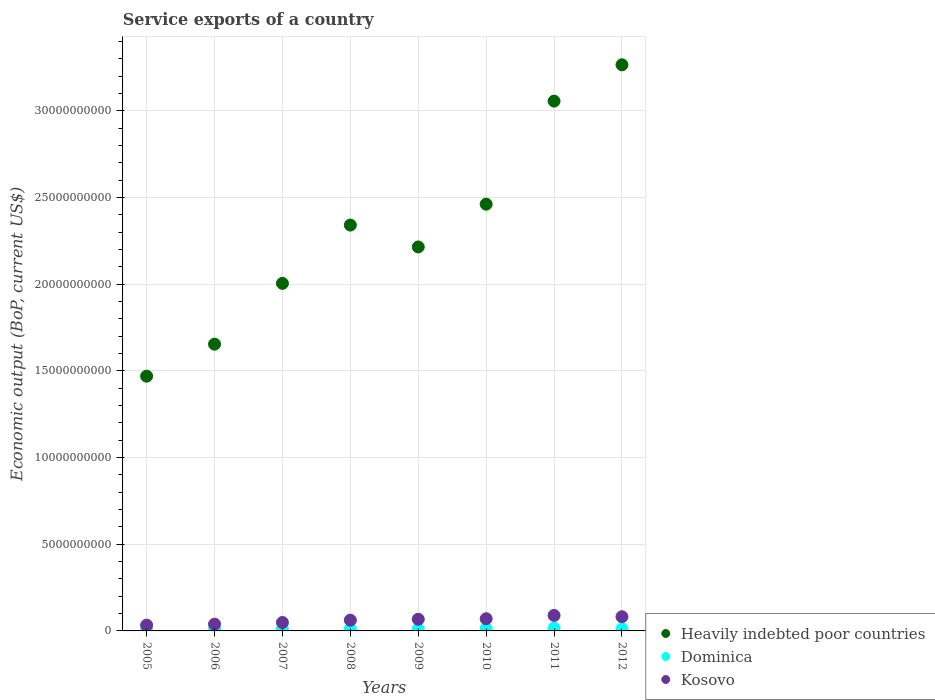What is the service exports in Kosovo in 2010?
Offer a terse response. 7.04e+08. Across all years, what is the maximum service exports in Dominica?
Provide a short and direct response. 1.55e+08. Across all years, what is the minimum service exports in Kosovo?
Your response must be concise. 3.33e+08. In which year was the service exports in Kosovo maximum?
Make the answer very short. 2011. What is the total service exports in Dominica in the graph?
Make the answer very short. 9.33e+08. What is the difference between the service exports in Dominica in 2009 and that in 2010?
Provide a short and direct response. -2.57e+07. What is the difference between the service exports in Kosovo in 2007 and the service exports in Heavily indebted poor countries in 2012?
Provide a short and direct response. -3.22e+1. What is the average service exports in Heavily indebted poor countries per year?
Your answer should be compact. 2.31e+1. In the year 2012, what is the difference between the service exports in Dominica and service exports in Heavily indebted poor countries?
Ensure brevity in your answer.  -3.25e+1. What is the ratio of the service exports in Kosovo in 2007 to that in 2009?
Make the answer very short. 0.72. Is the difference between the service exports in Dominica in 2007 and 2011 greater than the difference between the service exports in Heavily indebted poor countries in 2007 and 2011?
Provide a succinct answer. Yes. What is the difference between the highest and the second highest service exports in Dominica?
Your response must be concise. 1.80e+07. What is the difference between the highest and the lowest service exports in Kosovo?
Make the answer very short. 5.60e+08. In how many years, is the service exports in Dominica greater than the average service exports in Dominica taken over all years?
Offer a very short reply. 3. Is the sum of the service exports in Kosovo in 2005 and 2010 greater than the maximum service exports in Dominica across all years?
Your answer should be very brief. Yes. Is it the case that in every year, the sum of the service exports in Dominica and service exports in Kosovo  is greater than the service exports in Heavily indebted poor countries?
Keep it short and to the point. No. Is the service exports in Kosovo strictly less than the service exports in Heavily indebted poor countries over the years?
Give a very brief answer. Yes. How many dotlines are there?
Provide a succinct answer. 3. How many years are there in the graph?
Provide a short and direct response. 8. What is the difference between two consecutive major ticks on the Y-axis?
Your answer should be compact. 5.00e+09. Are the values on the major ticks of Y-axis written in scientific E-notation?
Ensure brevity in your answer.  No. Does the graph contain any zero values?
Your answer should be compact. No. Does the graph contain grids?
Keep it short and to the point. Yes. Where does the legend appear in the graph?
Offer a terse response. Bottom right. How are the legend labels stacked?
Your answer should be compact. Vertical. What is the title of the graph?
Your response must be concise. Service exports of a country. Does "Chad" appear as one of the legend labels in the graph?
Provide a succinct answer. No. What is the label or title of the X-axis?
Keep it short and to the point. Years. What is the label or title of the Y-axis?
Keep it short and to the point. Economic output (BoP, current US$). What is the Economic output (BoP, current US$) of Heavily indebted poor countries in 2005?
Your answer should be compact. 1.47e+1. What is the Economic output (BoP, current US$) in Dominica in 2005?
Provide a short and direct response. 8.64e+07. What is the Economic output (BoP, current US$) of Kosovo in 2005?
Your response must be concise. 3.33e+08. What is the Economic output (BoP, current US$) in Heavily indebted poor countries in 2006?
Your response must be concise. 1.65e+1. What is the Economic output (BoP, current US$) of Dominica in 2006?
Your answer should be very brief. 1.00e+08. What is the Economic output (BoP, current US$) of Kosovo in 2006?
Provide a succinct answer. 3.91e+08. What is the Economic output (BoP, current US$) in Heavily indebted poor countries in 2007?
Keep it short and to the point. 2.00e+1. What is the Economic output (BoP, current US$) of Dominica in 2007?
Keep it short and to the point. 1.09e+08. What is the Economic output (BoP, current US$) of Kosovo in 2007?
Provide a succinct answer. 4.86e+08. What is the Economic output (BoP, current US$) of Heavily indebted poor countries in 2008?
Provide a short and direct response. 2.34e+1. What is the Economic output (BoP, current US$) of Dominica in 2008?
Offer a very short reply. 1.13e+08. What is the Economic output (BoP, current US$) in Kosovo in 2008?
Ensure brevity in your answer.  6.20e+08. What is the Economic output (BoP, current US$) of Heavily indebted poor countries in 2009?
Provide a succinct answer. 2.21e+1. What is the Economic output (BoP, current US$) of Dominica in 2009?
Offer a very short reply. 1.11e+08. What is the Economic output (BoP, current US$) in Kosovo in 2009?
Your response must be concise. 6.73e+08. What is the Economic output (BoP, current US$) of Heavily indebted poor countries in 2010?
Ensure brevity in your answer.  2.46e+1. What is the Economic output (BoP, current US$) in Dominica in 2010?
Provide a short and direct response. 1.37e+08. What is the Economic output (BoP, current US$) of Kosovo in 2010?
Provide a short and direct response. 7.04e+08. What is the Economic output (BoP, current US$) of Heavily indebted poor countries in 2011?
Give a very brief answer. 3.06e+1. What is the Economic output (BoP, current US$) in Dominica in 2011?
Offer a very short reply. 1.55e+08. What is the Economic output (BoP, current US$) in Kosovo in 2011?
Make the answer very short. 8.93e+08. What is the Economic output (BoP, current US$) in Heavily indebted poor countries in 2012?
Provide a succinct answer. 3.27e+1. What is the Economic output (BoP, current US$) in Dominica in 2012?
Your response must be concise. 1.22e+08. What is the Economic output (BoP, current US$) of Kosovo in 2012?
Make the answer very short. 8.19e+08. Across all years, what is the maximum Economic output (BoP, current US$) in Heavily indebted poor countries?
Offer a very short reply. 3.27e+1. Across all years, what is the maximum Economic output (BoP, current US$) of Dominica?
Your answer should be compact. 1.55e+08. Across all years, what is the maximum Economic output (BoP, current US$) in Kosovo?
Offer a terse response. 8.93e+08. Across all years, what is the minimum Economic output (BoP, current US$) in Heavily indebted poor countries?
Keep it short and to the point. 1.47e+1. Across all years, what is the minimum Economic output (BoP, current US$) of Dominica?
Make the answer very short. 8.64e+07. Across all years, what is the minimum Economic output (BoP, current US$) of Kosovo?
Provide a succinct answer. 3.33e+08. What is the total Economic output (BoP, current US$) of Heavily indebted poor countries in the graph?
Offer a very short reply. 1.85e+11. What is the total Economic output (BoP, current US$) in Dominica in the graph?
Your answer should be very brief. 9.33e+08. What is the total Economic output (BoP, current US$) of Kosovo in the graph?
Provide a short and direct response. 4.92e+09. What is the difference between the Economic output (BoP, current US$) in Heavily indebted poor countries in 2005 and that in 2006?
Provide a succinct answer. -1.85e+09. What is the difference between the Economic output (BoP, current US$) in Dominica in 2005 and that in 2006?
Ensure brevity in your answer.  -1.37e+07. What is the difference between the Economic output (BoP, current US$) of Kosovo in 2005 and that in 2006?
Offer a terse response. -5.80e+07. What is the difference between the Economic output (BoP, current US$) in Heavily indebted poor countries in 2005 and that in 2007?
Your response must be concise. -5.35e+09. What is the difference between the Economic output (BoP, current US$) of Dominica in 2005 and that in 2007?
Keep it short and to the point. -2.24e+07. What is the difference between the Economic output (BoP, current US$) of Kosovo in 2005 and that in 2007?
Your answer should be very brief. -1.53e+08. What is the difference between the Economic output (BoP, current US$) of Heavily indebted poor countries in 2005 and that in 2008?
Provide a short and direct response. -8.71e+09. What is the difference between the Economic output (BoP, current US$) of Dominica in 2005 and that in 2008?
Provide a short and direct response. -2.64e+07. What is the difference between the Economic output (BoP, current US$) of Kosovo in 2005 and that in 2008?
Give a very brief answer. -2.87e+08. What is the difference between the Economic output (BoP, current US$) of Heavily indebted poor countries in 2005 and that in 2009?
Your answer should be compact. -7.45e+09. What is the difference between the Economic output (BoP, current US$) in Dominica in 2005 and that in 2009?
Provide a succinct answer. -2.47e+07. What is the difference between the Economic output (BoP, current US$) in Kosovo in 2005 and that in 2009?
Your answer should be compact. -3.40e+08. What is the difference between the Economic output (BoP, current US$) in Heavily indebted poor countries in 2005 and that in 2010?
Provide a short and direct response. -9.92e+09. What is the difference between the Economic output (BoP, current US$) in Dominica in 2005 and that in 2010?
Your answer should be very brief. -5.04e+07. What is the difference between the Economic output (BoP, current US$) in Kosovo in 2005 and that in 2010?
Offer a terse response. -3.71e+08. What is the difference between the Economic output (BoP, current US$) of Heavily indebted poor countries in 2005 and that in 2011?
Give a very brief answer. -1.59e+1. What is the difference between the Economic output (BoP, current US$) of Dominica in 2005 and that in 2011?
Offer a very short reply. -6.83e+07. What is the difference between the Economic output (BoP, current US$) in Kosovo in 2005 and that in 2011?
Offer a very short reply. -5.60e+08. What is the difference between the Economic output (BoP, current US$) of Heavily indebted poor countries in 2005 and that in 2012?
Ensure brevity in your answer.  -1.80e+1. What is the difference between the Economic output (BoP, current US$) of Dominica in 2005 and that in 2012?
Make the answer very short. -3.52e+07. What is the difference between the Economic output (BoP, current US$) in Kosovo in 2005 and that in 2012?
Offer a very short reply. -4.85e+08. What is the difference between the Economic output (BoP, current US$) of Heavily indebted poor countries in 2006 and that in 2007?
Offer a terse response. -3.51e+09. What is the difference between the Economic output (BoP, current US$) of Dominica in 2006 and that in 2007?
Your response must be concise. -8.65e+06. What is the difference between the Economic output (BoP, current US$) of Kosovo in 2006 and that in 2007?
Provide a short and direct response. -9.52e+07. What is the difference between the Economic output (BoP, current US$) in Heavily indebted poor countries in 2006 and that in 2008?
Make the answer very short. -6.87e+09. What is the difference between the Economic output (BoP, current US$) in Dominica in 2006 and that in 2008?
Give a very brief answer. -1.27e+07. What is the difference between the Economic output (BoP, current US$) in Kosovo in 2006 and that in 2008?
Your answer should be compact. -2.29e+08. What is the difference between the Economic output (BoP, current US$) of Heavily indebted poor countries in 2006 and that in 2009?
Your answer should be very brief. -5.61e+09. What is the difference between the Economic output (BoP, current US$) in Dominica in 2006 and that in 2009?
Keep it short and to the point. -1.10e+07. What is the difference between the Economic output (BoP, current US$) in Kosovo in 2006 and that in 2009?
Keep it short and to the point. -2.82e+08. What is the difference between the Economic output (BoP, current US$) of Heavily indebted poor countries in 2006 and that in 2010?
Provide a succinct answer. -8.07e+09. What is the difference between the Economic output (BoP, current US$) of Dominica in 2006 and that in 2010?
Ensure brevity in your answer.  -3.67e+07. What is the difference between the Economic output (BoP, current US$) of Kosovo in 2006 and that in 2010?
Keep it short and to the point. -3.13e+08. What is the difference between the Economic output (BoP, current US$) in Heavily indebted poor countries in 2006 and that in 2011?
Offer a terse response. -1.40e+1. What is the difference between the Economic output (BoP, current US$) of Dominica in 2006 and that in 2011?
Your answer should be very brief. -5.46e+07. What is the difference between the Economic output (BoP, current US$) of Kosovo in 2006 and that in 2011?
Provide a short and direct response. -5.02e+08. What is the difference between the Economic output (BoP, current US$) in Heavily indebted poor countries in 2006 and that in 2012?
Keep it short and to the point. -1.61e+1. What is the difference between the Economic output (BoP, current US$) in Dominica in 2006 and that in 2012?
Offer a terse response. -2.15e+07. What is the difference between the Economic output (BoP, current US$) of Kosovo in 2006 and that in 2012?
Offer a very short reply. -4.27e+08. What is the difference between the Economic output (BoP, current US$) in Heavily indebted poor countries in 2007 and that in 2008?
Offer a very short reply. -3.36e+09. What is the difference between the Economic output (BoP, current US$) in Dominica in 2007 and that in 2008?
Your answer should be compact. -4.02e+06. What is the difference between the Economic output (BoP, current US$) of Kosovo in 2007 and that in 2008?
Keep it short and to the point. -1.34e+08. What is the difference between the Economic output (BoP, current US$) of Heavily indebted poor countries in 2007 and that in 2009?
Offer a terse response. -2.10e+09. What is the difference between the Economic output (BoP, current US$) in Dominica in 2007 and that in 2009?
Provide a succinct answer. -2.31e+06. What is the difference between the Economic output (BoP, current US$) in Kosovo in 2007 and that in 2009?
Provide a succinct answer. -1.87e+08. What is the difference between the Economic output (BoP, current US$) of Heavily indebted poor countries in 2007 and that in 2010?
Provide a short and direct response. -4.57e+09. What is the difference between the Economic output (BoP, current US$) of Dominica in 2007 and that in 2010?
Give a very brief answer. -2.80e+07. What is the difference between the Economic output (BoP, current US$) of Kosovo in 2007 and that in 2010?
Provide a short and direct response. -2.17e+08. What is the difference between the Economic output (BoP, current US$) of Heavily indebted poor countries in 2007 and that in 2011?
Your answer should be very brief. -1.05e+1. What is the difference between the Economic output (BoP, current US$) of Dominica in 2007 and that in 2011?
Your response must be concise. -4.60e+07. What is the difference between the Economic output (BoP, current US$) in Kosovo in 2007 and that in 2011?
Keep it short and to the point. -4.07e+08. What is the difference between the Economic output (BoP, current US$) in Heavily indebted poor countries in 2007 and that in 2012?
Offer a terse response. -1.26e+1. What is the difference between the Economic output (BoP, current US$) in Dominica in 2007 and that in 2012?
Your answer should be very brief. -1.28e+07. What is the difference between the Economic output (BoP, current US$) in Kosovo in 2007 and that in 2012?
Offer a very short reply. -3.32e+08. What is the difference between the Economic output (BoP, current US$) of Heavily indebted poor countries in 2008 and that in 2009?
Provide a succinct answer. 1.26e+09. What is the difference between the Economic output (BoP, current US$) in Dominica in 2008 and that in 2009?
Provide a short and direct response. 1.71e+06. What is the difference between the Economic output (BoP, current US$) in Kosovo in 2008 and that in 2009?
Provide a succinct answer. -5.27e+07. What is the difference between the Economic output (BoP, current US$) in Heavily indebted poor countries in 2008 and that in 2010?
Offer a very short reply. -1.20e+09. What is the difference between the Economic output (BoP, current US$) of Dominica in 2008 and that in 2010?
Your answer should be very brief. -2.40e+07. What is the difference between the Economic output (BoP, current US$) of Kosovo in 2008 and that in 2010?
Provide a short and direct response. -8.37e+07. What is the difference between the Economic output (BoP, current US$) of Heavily indebted poor countries in 2008 and that in 2011?
Make the answer very short. -7.15e+09. What is the difference between the Economic output (BoP, current US$) of Dominica in 2008 and that in 2011?
Your answer should be very brief. -4.19e+07. What is the difference between the Economic output (BoP, current US$) in Kosovo in 2008 and that in 2011?
Ensure brevity in your answer.  -2.73e+08. What is the difference between the Economic output (BoP, current US$) in Heavily indebted poor countries in 2008 and that in 2012?
Make the answer very short. -9.24e+09. What is the difference between the Economic output (BoP, current US$) in Dominica in 2008 and that in 2012?
Keep it short and to the point. -8.82e+06. What is the difference between the Economic output (BoP, current US$) in Kosovo in 2008 and that in 2012?
Provide a short and direct response. -1.98e+08. What is the difference between the Economic output (BoP, current US$) of Heavily indebted poor countries in 2009 and that in 2010?
Your response must be concise. -2.47e+09. What is the difference between the Economic output (BoP, current US$) in Dominica in 2009 and that in 2010?
Provide a succinct answer. -2.57e+07. What is the difference between the Economic output (BoP, current US$) in Kosovo in 2009 and that in 2010?
Offer a terse response. -3.09e+07. What is the difference between the Economic output (BoP, current US$) in Heavily indebted poor countries in 2009 and that in 2011?
Your response must be concise. -8.41e+09. What is the difference between the Economic output (BoP, current US$) in Dominica in 2009 and that in 2011?
Offer a terse response. -4.37e+07. What is the difference between the Economic output (BoP, current US$) in Kosovo in 2009 and that in 2011?
Provide a succinct answer. -2.20e+08. What is the difference between the Economic output (BoP, current US$) of Heavily indebted poor countries in 2009 and that in 2012?
Keep it short and to the point. -1.05e+1. What is the difference between the Economic output (BoP, current US$) of Dominica in 2009 and that in 2012?
Offer a very short reply. -1.05e+07. What is the difference between the Economic output (BoP, current US$) of Kosovo in 2009 and that in 2012?
Your answer should be compact. -1.46e+08. What is the difference between the Economic output (BoP, current US$) in Heavily indebted poor countries in 2010 and that in 2011?
Keep it short and to the point. -5.94e+09. What is the difference between the Economic output (BoP, current US$) in Dominica in 2010 and that in 2011?
Keep it short and to the point. -1.80e+07. What is the difference between the Economic output (BoP, current US$) of Kosovo in 2010 and that in 2011?
Provide a succinct answer. -1.89e+08. What is the difference between the Economic output (BoP, current US$) in Heavily indebted poor countries in 2010 and that in 2012?
Your answer should be very brief. -8.04e+09. What is the difference between the Economic output (BoP, current US$) of Dominica in 2010 and that in 2012?
Your answer should be very brief. 1.51e+07. What is the difference between the Economic output (BoP, current US$) of Kosovo in 2010 and that in 2012?
Your answer should be compact. -1.15e+08. What is the difference between the Economic output (BoP, current US$) of Heavily indebted poor countries in 2011 and that in 2012?
Make the answer very short. -2.09e+09. What is the difference between the Economic output (BoP, current US$) in Dominica in 2011 and that in 2012?
Offer a terse response. 3.31e+07. What is the difference between the Economic output (BoP, current US$) in Kosovo in 2011 and that in 2012?
Keep it short and to the point. 7.44e+07. What is the difference between the Economic output (BoP, current US$) in Heavily indebted poor countries in 2005 and the Economic output (BoP, current US$) in Dominica in 2006?
Your answer should be compact. 1.46e+1. What is the difference between the Economic output (BoP, current US$) of Heavily indebted poor countries in 2005 and the Economic output (BoP, current US$) of Kosovo in 2006?
Provide a succinct answer. 1.43e+1. What is the difference between the Economic output (BoP, current US$) in Dominica in 2005 and the Economic output (BoP, current US$) in Kosovo in 2006?
Your answer should be compact. -3.05e+08. What is the difference between the Economic output (BoP, current US$) of Heavily indebted poor countries in 2005 and the Economic output (BoP, current US$) of Dominica in 2007?
Make the answer very short. 1.46e+1. What is the difference between the Economic output (BoP, current US$) in Heavily indebted poor countries in 2005 and the Economic output (BoP, current US$) in Kosovo in 2007?
Provide a short and direct response. 1.42e+1. What is the difference between the Economic output (BoP, current US$) in Dominica in 2005 and the Economic output (BoP, current US$) in Kosovo in 2007?
Keep it short and to the point. -4.00e+08. What is the difference between the Economic output (BoP, current US$) of Heavily indebted poor countries in 2005 and the Economic output (BoP, current US$) of Dominica in 2008?
Your answer should be compact. 1.46e+1. What is the difference between the Economic output (BoP, current US$) in Heavily indebted poor countries in 2005 and the Economic output (BoP, current US$) in Kosovo in 2008?
Keep it short and to the point. 1.41e+1. What is the difference between the Economic output (BoP, current US$) of Dominica in 2005 and the Economic output (BoP, current US$) of Kosovo in 2008?
Offer a terse response. -5.34e+08. What is the difference between the Economic output (BoP, current US$) in Heavily indebted poor countries in 2005 and the Economic output (BoP, current US$) in Dominica in 2009?
Provide a succinct answer. 1.46e+1. What is the difference between the Economic output (BoP, current US$) of Heavily indebted poor countries in 2005 and the Economic output (BoP, current US$) of Kosovo in 2009?
Offer a very short reply. 1.40e+1. What is the difference between the Economic output (BoP, current US$) of Dominica in 2005 and the Economic output (BoP, current US$) of Kosovo in 2009?
Provide a succinct answer. -5.87e+08. What is the difference between the Economic output (BoP, current US$) in Heavily indebted poor countries in 2005 and the Economic output (BoP, current US$) in Dominica in 2010?
Offer a very short reply. 1.46e+1. What is the difference between the Economic output (BoP, current US$) in Heavily indebted poor countries in 2005 and the Economic output (BoP, current US$) in Kosovo in 2010?
Provide a succinct answer. 1.40e+1. What is the difference between the Economic output (BoP, current US$) in Dominica in 2005 and the Economic output (BoP, current US$) in Kosovo in 2010?
Your answer should be compact. -6.17e+08. What is the difference between the Economic output (BoP, current US$) of Heavily indebted poor countries in 2005 and the Economic output (BoP, current US$) of Dominica in 2011?
Keep it short and to the point. 1.45e+1. What is the difference between the Economic output (BoP, current US$) of Heavily indebted poor countries in 2005 and the Economic output (BoP, current US$) of Kosovo in 2011?
Provide a succinct answer. 1.38e+1. What is the difference between the Economic output (BoP, current US$) of Dominica in 2005 and the Economic output (BoP, current US$) of Kosovo in 2011?
Provide a succinct answer. -8.07e+08. What is the difference between the Economic output (BoP, current US$) in Heavily indebted poor countries in 2005 and the Economic output (BoP, current US$) in Dominica in 2012?
Keep it short and to the point. 1.46e+1. What is the difference between the Economic output (BoP, current US$) in Heavily indebted poor countries in 2005 and the Economic output (BoP, current US$) in Kosovo in 2012?
Give a very brief answer. 1.39e+1. What is the difference between the Economic output (BoP, current US$) in Dominica in 2005 and the Economic output (BoP, current US$) in Kosovo in 2012?
Your response must be concise. -7.32e+08. What is the difference between the Economic output (BoP, current US$) in Heavily indebted poor countries in 2006 and the Economic output (BoP, current US$) in Dominica in 2007?
Keep it short and to the point. 1.64e+1. What is the difference between the Economic output (BoP, current US$) of Heavily indebted poor countries in 2006 and the Economic output (BoP, current US$) of Kosovo in 2007?
Make the answer very short. 1.61e+1. What is the difference between the Economic output (BoP, current US$) of Dominica in 2006 and the Economic output (BoP, current US$) of Kosovo in 2007?
Give a very brief answer. -3.86e+08. What is the difference between the Economic output (BoP, current US$) in Heavily indebted poor countries in 2006 and the Economic output (BoP, current US$) in Dominica in 2008?
Your answer should be compact. 1.64e+1. What is the difference between the Economic output (BoP, current US$) of Heavily indebted poor countries in 2006 and the Economic output (BoP, current US$) of Kosovo in 2008?
Offer a terse response. 1.59e+1. What is the difference between the Economic output (BoP, current US$) in Dominica in 2006 and the Economic output (BoP, current US$) in Kosovo in 2008?
Offer a very short reply. -5.20e+08. What is the difference between the Economic output (BoP, current US$) in Heavily indebted poor countries in 2006 and the Economic output (BoP, current US$) in Dominica in 2009?
Offer a terse response. 1.64e+1. What is the difference between the Economic output (BoP, current US$) of Heavily indebted poor countries in 2006 and the Economic output (BoP, current US$) of Kosovo in 2009?
Give a very brief answer. 1.59e+1. What is the difference between the Economic output (BoP, current US$) in Dominica in 2006 and the Economic output (BoP, current US$) in Kosovo in 2009?
Provide a succinct answer. -5.73e+08. What is the difference between the Economic output (BoP, current US$) in Heavily indebted poor countries in 2006 and the Economic output (BoP, current US$) in Dominica in 2010?
Your response must be concise. 1.64e+1. What is the difference between the Economic output (BoP, current US$) of Heavily indebted poor countries in 2006 and the Economic output (BoP, current US$) of Kosovo in 2010?
Your response must be concise. 1.58e+1. What is the difference between the Economic output (BoP, current US$) of Dominica in 2006 and the Economic output (BoP, current US$) of Kosovo in 2010?
Your answer should be compact. -6.04e+08. What is the difference between the Economic output (BoP, current US$) in Heavily indebted poor countries in 2006 and the Economic output (BoP, current US$) in Dominica in 2011?
Provide a succinct answer. 1.64e+1. What is the difference between the Economic output (BoP, current US$) in Heavily indebted poor countries in 2006 and the Economic output (BoP, current US$) in Kosovo in 2011?
Offer a terse response. 1.56e+1. What is the difference between the Economic output (BoP, current US$) of Dominica in 2006 and the Economic output (BoP, current US$) of Kosovo in 2011?
Your answer should be compact. -7.93e+08. What is the difference between the Economic output (BoP, current US$) of Heavily indebted poor countries in 2006 and the Economic output (BoP, current US$) of Dominica in 2012?
Provide a succinct answer. 1.64e+1. What is the difference between the Economic output (BoP, current US$) of Heavily indebted poor countries in 2006 and the Economic output (BoP, current US$) of Kosovo in 2012?
Provide a succinct answer. 1.57e+1. What is the difference between the Economic output (BoP, current US$) in Dominica in 2006 and the Economic output (BoP, current US$) in Kosovo in 2012?
Offer a terse response. -7.18e+08. What is the difference between the Economic output (BoP, current US$) of Heavily indebted poor countries in 2007 and the Economic output (BoP, current US$) of Dominica in 2008?
Make the answer very short. 1.99e+1. What is the difference between the Economic output (BoP, current US$) of Heavily indebted poor countries in 2007 and the Economic output (BoP, current US$) of Kosovo in 2008?
Your answer should be very brief. 1.94e+1. What is the difference between the Economic output (BoP, current US$) in Dominica in 2007 and the Economic output (BoP, current US$) in Kosovo in 2008?
Provide a succinct answer. -5.11e+08. What is the difference between the Economic output (BoP, current US$) in Heavily indebted poor countries in 2007 and the Economic output (BoP, current US$) in Dominica in 2009?
Keep it short and to the point. 1.99e+1. What is the difference between the Economic output (BoP, current US$) in Heavily indebted poor countries in 2007 and the Economic output (BoP, current US$) in Kosovo in 2009?
Give a very brief answer. 1.94e+1. What is the difference between the Economic output (BoP, current US$) in Dominica in 2007 and the Economic output (BoP, current US$) in Kosovo in 2009?
Ensure brevity in your answer.  -5.64e+08. What is the difference between the Economic output (BoP, current US$) in Heavily indebted poor countries in 2007 and the Economic output (BoP, current US$) in Dominica in 2010?
Offer a terse response. 1.99e+1. What is the difference between the Economic output (BoP, current US$) in Heavily indebted poor countries in 2007 and the Economic output (BoP, current US$) in Kosovo in 2010?
Keep it short and to the point. 1.93e+1. What is the difference between the Economic output (BoP, current US$) in Dominica in 2007 and the Economic output (BoP, current US$) in Kosovo in 2010?
Ensure brevity in your answer.  -5.95e+08. What is the difference between the Economic output (BoP, current US$) of Heavily indebted poor countries in 2007 and the Economic output (BoP, current US$) of Dominica in 2011?
Your answer should be compact. 1.99e+1. What is the difference between the Economic output (BoP, current US$) of Heavily indebted poor countries in 2007 and the Economic output (BoP, current US$) of Kosovo in 2011?
Make the answer very short. 1.92e+1. What is the difference between the Economic output (BoP, current US$) of Dominica in 2007 and the Economic output (BoP, current US$) of Kosovo in 2011?
Give a very brief answer. -7.84e+08. What is the difference between the Economic output (BoP, current US$) in Heavily indebted poor countries in 2007 and the Economic output (BoP, current US$) in Dominica in 2012?
Your answer should be very brief. 1.99e+1. What is the difference between the Economic output (BoP, current US$) of Heavily indebted poor countries in 2007 and the Economic output (BoP, current US$) of Kosovo in 2012?
Provide a short and direct response. 1.92e+1. What is the difference between the Economic output (BoP, current US$) of Dominica in 2007 and the Economic output (BoP, current US$) of Kosovo in 2012?
Give a very brief answer. -7.10e+08. What is the difference between the Economic output (BoP, current US$) of Heavily indebted poor countries in 2008 and the Economic output (BoP, current US$) of Dominica in 2009?
Ensure brevity in your answer.  2.33e+1. What is the difference between the Economic output (BoP, current US$) of Heavily indebted poor countries in 2008 and the Economic output (BoP, current US$) of Kosovo in 2009?
Provide a short and direct response. 2.27e+1. What is the difference between the Economic output (BoP, current US$) of Dominica in 2008 and the Economic output (BoP, current US$) of Kosovo in 2009?
Your answer should be compact. -5.60e+08. What is the difference between the Economic output (BoP, current US$) in Heavily indebted poor countries in 2008 and the Economic output (BoP, current US$) in Dominica in 2010?
Ensure brevity in your answer.  2.33e+1. What is the difference between the Economic output (BoP, current US$) of Heavily indebted poor countries in 2008 and the Economic output (BoP, current US$) of Kosovo in 2010?
Your response must be concise. 2.27e+1. What is the difference between the Economic output (BoP, current US$) of Dominica in 2008 and the Economic output (BoP, current US$) of Kosovo in 2010?
Offer a terse response. -5.91e+08. What is the difference between the Economic output (BoP, current US$) of Heavily indebted poor countries in 2008 and the Economic output (BoP, current US$) of Dominica in 2011?
Offer a terse response. 2.33e+1. What is the difference between the Economic output (BoP, current US$) in Heavily indebted poor countries in 2008 and the Economic output (BoP, current US$) in Kosovo in 2011?
Provide a short and direct response. 2.25e+1. What is the difference between the Economic output (BoP, current US$) of Dominica in 2008 and the Economic output (BoP, current US$) of Kosovo in 2011?
Make the answer very short. -7.80e+08. What is the difference between the Economic output (BoP, current US$) of Heavily indebted poor countries in 2008 and the Economic output (BoP, current US$) of Dominica in 2012?
Keep it short and to the point. 2.33e+1. What is the difference between the Economic output (BoP, current US$) of Heavily indebted poor countries in 2008 and the Economic output (BoP, current US$) of Kosovo in 2012?
Provide a short and direct response. 2.26e+1. What is the difference between the Economic output (BoP, current US$) of Dominica in 2008 and the Economic output (BoP, current US$) of Kosovo in 2012?
Offer a terse response. -7.06e+08. What is the difference between the Economic output (BoP, current US$) in Heavily indebted poor countries in 2009 and the Economic output (BoP, current US$) in Dominica in 2010?
Give a very brief answer. 2.20e+1. What is the difference between the Economic output (BoP, current US$) in Heavily indebted poor countries in 2009 and the Economic output (BoP, current US$) in Kosovo in 2010?
Give a very brief answer. 2.14e+1. What is the difference between the Economic output (BoP, current US$) of Dominica in 2009 and the Economic output (BoP, current US$) of Kosovo in 2010?
Give a very brief answer. -5.93e+08. What is the difference between the Economic output (BoP, current US$) in Heavily indebted poor countries in 2009 and the Economic output (BoP, current US$) in Dominica in 2011?
Offer a terse response. 2.20e+1. What is the difference between the Economic output (BoP, current US$) in Heavily indebted poor countries in 2009 and the Economic output (BoP, current US$) in Kosovo in 2011?
Offer a terse response. 2.13e+1. What is the difference between the Economic output (BoP, current US$) in Dominica in 2009 and the Economic output (BoP, current US$) in Kosovo in 2011?
Your answer should be compact. -7.82e+08. What is the difference between the Economic output (BoP, current US$) of Heavily indebted poor countries in 2009 and the Economic output (BoP, current US$) of Dominica in 2012?
Offer a terse response. 2.20e+1. What is the difference between the Economic output (BoP, current US$) in Heavily indebted poor countries in 2009 and the Economic output (BoP, current US$) in Kosovo in 2012?
Make the answer very short. 2.13e+1. What is the difference between the Economic output (BoP, current US$) in Dominica in 2009 and the Economic output (BoP, current US$) in Kosovo in 2012?
Your response must be concise. -7.07e+08. What is the difference between the Economic output (BoP, current US$) in Heavily indebted poor countries in 2010 and the Economic output (BoP, current US$) in Dominica in 2011?
Your answer should be very brief. 2.45e+1. What is the difference between the Economic output (BoP, current US$) of Heavily indebted poor countries in 2010 and the Economic output (BoP, current US$) of Kosovo in 2011?
Your answer should be compact. 2.37e+1. What is the difference between the Economic output (BoP, current US$) in Dominica in 2010 and the Economic output (BoP, current US$) in Kosovo in 2011?
Offer a terse response. -7.56e+08. What is the difference between the Economic output (BoP, current US$) in Heavily indebted poor countries in 2010 and the Economic output (BoP, current US$) in Dominica in 2012?
Your response must be concise. 2.45e+1. What is the difference between the Economic output (BoP, current US$) in Heavily indebted poor countries in 2010 and the Economic output (BoP, current US$) in Kosovo in 2012?
Give a very brief answer. 2.38e+1. What is the difference between the Economic output (BoP, current US$) of Dominica in 2010 and the Economic output (BoP, current US$) of Kosovo in 2012?
Your response must be concise. -6.82e+08. What is the difference between the Economic output (BoP, current US$) of Heavily indebted poor countries in 2011 and the Economic output (BoP, current US$) of Dominica in 2012?
Offer a very short reply. 3.04e+1. What is the difference between the Economic output (BoP, current US$) of Heavily indebted poor countries in 2011 and the Economic output (BoP, current US$) of Kosovo in 2012?
Offer a very short reply. 2.97e+1. What is the difference between the Economic output (BoP, current US$) in Dominica in 2011 and the Economic output (BoP, current US$) in Kosovo in 2012?
Ensure brevity in your answer.  -6.64e+08. What is the average Economic output (BoP, current US$) in Heavily indebted poor countries per year?
Offer a very short reply. 2.31e+1. What is the average Economic output (BoP, current US$) in Dominica per year?
Make the answer very short. 1.17e+08. What is the average Economic output (BoP, current US$) in Kosovo per year?
Keep it short and to the point. 6.15e+08. In the year 2005, what is the difference between the Economic output (BoP, current US$) of Heavily indebted poor countries and Economic output (BoP, current US$) of Dominica?
Your response must be concise. 1.46e+1. In the year 2005, what is the difference between the Economic output (BoP, current US$) of Heavily indebted poor countries and Economic output (BoP, current US$) of Kosovo?
Offer a very short reply. 1.44e+1. In the year 2005, what is the difference between the Economic output (BoP, current US$) of Dominica and Economic output (BoP, current US$) of Kosovo?
Offer a terse response. -2.47e+08. In the year 2006, what is the difference between the Economic output (BoP, current US$) of Heavily indebted poor countries and Economic output (BoP, current US$) of Dominica?
Your answer should be very brief. 1.64e+1. In the year 2006, what is the difference between the Economic output (BoP, current US$) in Heavily indebted poor countries and Economic output (BoP, current US$) in Kosovo?
Give a very brief answer. 1.61e+1. In the year 2006, what is the difference between the Economic output (BoP, current US$) of Dominica and Economic output (BoP, current US$) of Kosovo?
Provide a succinct answer. -2.91e+08. In the year 2007, what is the difference between the Economic output (BoP, current US$) in Heavily indebted poor countries and Economic output (BoP, current US$) in Dominica?
Your response must be concise. 1.99e+1. In the year 2007, what is the difference between the Economic output (BoP, current US$) of Heavily indebted poor countries and Economic output (BoP, current US$) of Kosovo?
Provide a short and direct response. 1.96e+1. In the year 2007, what is the difference between the Economic output (BoP, current US$) in Dominica and Economic output (BoP, current US$) in Kosovo?
Make the answer very short. -3.78e+08. In the year 2008, what is the difference between the Economic output (BoP, current US$) in Heavily indebted poor countries and Economic output (BoP, current US$) in Dominica?
Your answer should be very brief. 2.33e+1. In the year 2008, what is the difference between the Economic output (BoP, current US$) of Heavily indebted poor countries and Economic output (BoP, current US$) of Kosovo?
Provide a succinct answer. 2.28e+1. In the year 2008, what is the difference between the Economic output (BoP, current US$) of Dominica and Economic output (BoP, current US$) of Kosovo?
Make the answer very short. -5.07e+08. In the year 2009, what is the difference between the Economic output (BoP, current US$) of Heavily indebted poor countries and Economic output (BoP, current US$) of Dominica?
Provide a short and direct response. 2.20e+1. In the year 2009, what is the difference between the Economic output (BoP, current US$) of Heavily indebted poor countries and Economic output (BoP, current US$) of Kosovo?
Provide a succinct answer. 2.15e+1. In the year 2009, what is the difference between the Economic output (BoP, current US$) of Dominica and Economic output (BoP, current US$) of Kosovo?
Provide a short and direct response. -5.62e+08. In the year 2010, what is the difference between the Economic output (BoP, current US$) of Heavily indebted poor countries and Economic output (BoP, current US$) of Dominica?
Keep it short and to the point. 2.45e+1. In the year 2010, what is the difference between the Economic output (BoP, current US$) in Heavily indebted poor countries and Economic output (BoP, current US$) in Kosovo?
Offer a terse response. 2.39e+1. In the year 2010, what is the difference between the Economic output (BoP, current US$) in Dominica and Economic output (BoP, current US$) in Kosovo?
Offer a terse response. -5.67e+08. In the year 2011, what is the difference between the Economic output (BoP, current US$) in Heavily indebted poor countries and Economic output (BoP, current US$) in Dominica?
Make the answer very short. 3.04e+1. In the year 2011, what is the difference between the Economic output (BoP, current US$) in Heavily indebted poor countries and Economic output (BoP, current US$) in Kosovo?
Your answer should be compact. 2.97e+1. In the year 2011, what is the difference between the Economic output (BoP, current US$) of Dominica and Economic output (BoP, current US$) of Kosovo?
Keep it short and to the point. -7.38e+08. In the year 2012, what is the difference between the Economic output (BoP, current US$) of Heavily indebted poor countries and Economic output (BoP, current US$) of Dominica?
Ensure brevity in your answer.  3.25e+1. In the year 2012, what is the difference between the Economic output (BoP, current US$) of Heavily indebted poor countries and Economic output (BoP, current US$) of Kosovo?
Keep it short and to the point. 3.18e+1. In the year 2012, what is the difference between the Economic output (BoP, current US$) in Dominica and Economic output (BoP, current US$) in Kosovo?
Provide a short and direct response. -6.97e+08. What is the ratio of the Economic output (BoP, current US$) in Heavily indebted poor countries in 2005 to that in 2006?
Keep it short and to the point. 0.89. What is the ratio of the Economic output (BoP, current US$) in Dominica in 2005 to that in 2006?
Your answer should be very brief. 0.86. What is the ratio of the Economic output (BoP, current US$) of Kosovo in 2005 to that in 2006?
Provide a short and direct response. 0.85. What is the ratio of the Economic output (BoP, current US$) of Heavily indebted poor countries in 2005 to that in 2007?
Offer a very short reply. 0.73. What is the ratio of the Economic output (BoP, current US$) of Dominica in 2005 to that in 2007?
Provide a short and direct response. 0.79. What is the ratio of the Economic output (BoP, current US$) in Kosovo in 2005 to that in 2007?
Ensure brevity in your answer.  0.68. What is the ratio of the Economic output (BoP, current US$) of Heavily indebted poor countries in 2005 to that in 2008?
Keep it short and to the point. 0.63. What is the ratio of the Economic output (BoP, current US$) in Dominica in 2005 to that in 2008?
Provide a short and direct response. 0.77. What is the ratio of the Economic output (BoP, current US$) in Kosovo in 2005 to that in 2008?
Your answer should be very brief. 0.54. What is the ratio of the Economic output (BoP, current US$) of Heavily indebted poor countries in 2005 to that in 2009?
Keep it short and to the point. 0.66. What is the ratio of the Economic output (BoP, current US$) of Dominica in 2005 to that in 2009?
Keep it short and to the point. 0.78. What is the ratio of the Economic output (BoP, current US$) in Kosovo in 2005 to that in 2009?
Offer a terse response. 0.5. What is the ratio of the Economic output (BoP, current US$) in Heavily indebted poor countries in 2005 to that in 2010?
Give a very brief answer. 0.6. What is the ratio of the Economic output (BoP, current US$) in Dominica in 2005 to that in 2010?
Your answer should be very brief. 0.63. What is the ratio of the Economic output (BoP, current US$) in Kosovo in 2005 to that in 2010?
Provide a succinct answer. 0.47. What is the ratio of the Economic output (BoP, current US$) in Heavily indebted poor countries in 2005 to that in 2011?
Offer a very short reply. 0.48. What is the ratio of the Economic output (BoP, current US$) of Dominica in 2005 to that in 2011?
Keep it short and to the point. 0.56. What is the ratio of the Economic output (BoP, current US$) of Kosovo in 2005 to that in 2011?
Your answer should be very brief. 0.37. What is the ratio of the Economic output (BoP, current US$) of Heavily indebted poor countries in 2005 to that in 2012?
Make the answer very short. 0.45. What is the ratio of the Economic output (BoP, current US$) of Dominica in 2005 to that in 2012?
Make the answer very short. 0.71. What is the ratio of the Economic output (BoP, current US$) in Kosovo in 2005 to that in 2012?
Provide a short and direct response. 0.41. What is the ratio of the Economic output (BoP, current US$) in Heavily indebted poor countries in 2006 to that in 2007?
Your response must be concise. 0.83. What is the ratio of the Economic output (BoP, current US$) in Dominica in 2006 to that in 2007?
Keep it short and to the point. 0.92. What is the ratio of the Economic output (BoP, current US$) in Kosovo in 2006 to that in 2007?
Provide a succinct answer. 0.8. What is the ratio of the Economic output (BoP, current US$) of Heavily indebted poor countries in 2006 to that in 2008?
Offer a terse response. 0.71. What is the ratio of the Economic output (BoP, current US$) of Dominica in 2006 to that in 2008?
Provide a succinct answer. 0.89. What is the ratio of the Economic output (BoP, current US$) in Kosovo in 2006 to that in 2008?
Make the answer very short. 0.63. What is the ratio of the Economic output (BoP, current US$) of Heavily indebted poor countries in 2006 to that in 2009?
Offer a very short reply. 0.75. What is the ratio of the Economic output (BoP, current US$) in Dominica in 2006 to that in 2009?
Offer a very short reply. 0.9. What is the ratio of the Economic output (BoP, current US$) of Kosovo in 2006 to that in 2009?
Keep it short and to the point. 0.58. What is the ratio of the Economic output (BoP, current US$) in Heavily indebted poor countries in 2006 to that in 2010?
Give a very brief answer. 0.67. What is the ratio of the Economic output (BoP, current US$) of Dominica in 2006 to that in 2010?
Provide a succinct answer. 0.73. What is the ratio of the Economic output (BoP, current US$) in Kosovo in 2006 to that in 2010?
Your answer should be compact. 0.56. What is the ratio of the Economic output (BoP, current US$) in Heavily indebted poor countries in 2006 to that in 2011?
Your answer should be very brief. 0.54. What is the ratio of the Economic output (BoP, current US$) in Dominica in 2006 to that in 2011?
Ensure brevity in your answer.  0.65. What is the ratio of the Economic output (BoP, current US$) of Kosovo in 2006 to that in 2011?
Your answer should be compact. 0.44. What is the ratio of the Economic output (BoP, current US$) of Heavily indebted poor countries in 2006 to that in 2012?
Your response must be concise. 0.51. What is the ratio of the Economic output (BoP, current US$) of Dominica in 2006 to that in 2012?
Your answer should be compact. 0.82. What is the ratio of the Economic output (BoP, current US$) in Kosovo in 2006 to that in 2012?
Offer a very short reply. 0.48. What is the ratio of the Economic output (BoP, current US$) in Heavily indebted poor countries in 2007 to that in 2008?
Your answer should be very brief. 0.86. What is the ratio of the Economic output (BoP, current US$) of Dominica in 2007 to that in 2008?
Your answer should be very brief. 0.96. What is the ratio of the Economic output (BoP, current US$) of Kosovo in 2007 to that in 2008?
Offer a terse response. 0.78. What is the ratio of the Economic output (BoP, current US$) in Heavily indebted poor countries in 2007 to that in 2009?
Ensure brevity in your answer.  0.91. What is the ratio of the Economic output (BoP, current US$) in Dominica in 2007 to that in 2009?
Your response must be concise. 0.98. What is the ratio of the Economic output (BoP, current US$) in Kosovo in 2007 to that in 2009?
Your response must be concise. 0.72. What is the ratio of the Economic output (BoP, current US$) of Heavily indebted poor countries in 2007 to that in 2010?
Offer a very short reply. 0.81. What is the ratio of the Economic output (BoP, current US$) of Dominica in 2007 to that in 2010?
Offer a very short reply. 0.8. What is the ratio of the Economic output (BoP, current US$) in Kosovo in 2007 to that in 2010?
Your response must be concise. 0.69. What is the ratio of the Economic output (BoP, current US$) in Heavily indebted poor countries in 2007 to that in 2011?
Offer a very short reply. 0.66. What is the ratio of the Economic output (BoP, current US$) in Dominica in 2007 to that in 2011?
Your answer should be compact. 0.7. What is the ratio of the Economic output (BoP, current US$) in Kosovo in 2007 to that in 2011?
Keep it short and to the point. 0.54. What is the ratio of the Economic output (BoP, current US$) in Heavily indebted poor countries in 2007 to that in 2012?
Offer a very short reply. 0.61. What is the ratio of the Economic output (BoP, current US$) of Dominica in 2007 to that in 2012?
Give a very brief answer. 0.89. What is the ratio of the Economic output (BoP, current US$) in Kosovo in 2007 to that in 2012?
Offer a terse response. 0.59. What is the ratio of the Economic output (BoP, current US$) of Heavily indebted poor countries in 2008 to that in 2009?
Keep it short and to the point. 1.06. What is the ratio of the Economic output (BoP, current US$) of Dominica in 2008 to that in 2009?
Provide a short and direct response. 1.02. What is the ratio of the Economic output (BoP, current US$) in Kosovo in 2008 to that in 2009?
Offer a very short reply. 0.92. What is the ratio of the Economic output (BoP, current US$) in Heavily indebted poor countries in 2008 to that in 2010?
Give a very brief answer. 0.95. What is the ratio of the Economic output (BoP, current US$) of Dominica in 2008 to that in 2010?
Offer a terse response. 0.82. What is the ratio of the Economic output (BoP, current US$) in Kosovo in 2008 to that in 2010?
Offer a terse response. 0.88. What is the ratio of the Economic output (BoP, current US$) in Heavily indebted poor countries in 2008 to that in 2011?
Keep it short and to the point. 0.77. What is the ratio of the Economic output (BoP, current US$) of Dominica in 2008 to that in 2011?
Give a very brief answer. 0.73. What is the ratio of the Economic output (BoP, current US$) of Kosovo in 2008 to that in 2011?
Provide a short and direct response. 0.69. What is the ratio of the Economic output (BoP, current US$) in Heavily indebted poor countries in 2008 to that in 2012?
Your answer should be very brief. 0.72. What is the ratio of the Economic output (BoP, current US$) in Dominica in 2008 to that in 2012?
Give a very brief answer. 0.93. What is the ratio of the Economic output (BoP, current US$) in Kosovo in 2008 to that in 2012?
Your answer should be compact. 0.76. What is the ratio of the Economic output (BoP, current US$) in Heavily indebted poor countries in 2009 to that in 2010?
Keep it short and to the point. 0.9. What is the ratio of the Economic output (BoP, current US$) of Dominica in 2009 to that in 2010?
Your response must be concise. 0.81. What is the ratio of the Economic output (BoP, current US$) in Kosovo in 2009 to that in 2010?
Provide a short and direct response. 0.96. What is the ratio of the Economic output (BoP, current US$) in Heavily indebted poor countries in 2009 to that in 2011?
Offer a very short reply. 0.72. What is the ratio of the Economic output (BoP, current US$) in Dominica in 2009 to that in 2011?
Your answer should be very brief. 0.72. What is the ratio of the Economic output (BoP, current US$) of Kosovo in 2009 to that in 2011?
Ensure brevity in your answer.  0.75. What is the ratio of the Economic output (BoP, current US$) in Heavily indebted poor countries in 2009 to that in 2012?
Make the answer very short. 0.68. What is the ratio of the Economic output (BoP, current US$) in Dominica in 2009 to that in 2012?
Provide a succinct answer. 0.91. What is the ratio of the Economic output (BoP, current US$) of Kosovo in 2009 to that in 2012?
Give a very brief answer. 0.82. What is the ratio of the Economic output (BoP, current US$) of Heavily indebted poor countries in 2010 to that in 2011?
Provide a succinct answer. 0.81. What is the ratio of the Economic output (BoP, current US$) in Dominica in 2010 to that in 2011?
Provide a succinct answer. 0.88. What is the ratio of the Economic output (BoP, current US$) of Kosovo in 2010 to that in 2011?
Ensure brevity in your answer.  0.79. What is the ratio of the Economic output (BoP, current US$) in Heavily indebted poor countries in 2010 to that in 2012?
Your answer should be very brief. 0.75. What is the ratio of the Economic output (BoP, current US$) of Dominica in 2010 to that in 2012?
Give a very brief answer. 1.12. What is the ratio of the Economic output (BoP, current US$) of Kosovo in 2010 to that in 2012?
Provide a succinct answer. 0.86. What is the ratio of the Economic output (BoP, current US$) in Heavily indebted poor countries in 2011 to that in 2012?
Provide a succinct answer. 0.94. What is the ratio of the Economic output (BoP, current US$) of Dominica in 2011 to that in 2012?
Ensure brevity in your answer.  1.27. What is the ratio of the Economic output (BoP, current US$) of Kosovo in 2011 to that in 2012?
Ensure brevity in your answer.  1.09. What is the difference between the highest and the second highest Economic output (BoP, current US$) of Heavily indebted poor countries?
Your answer should be compact. 2.09e+09. What is the difference between the highest and the second highest Economic output (BoP, current US$) of Dominica?
Give a very brief answer. 1.80e+07. What is the difference between the highest and the second highest Economic output (BoP, current US$) in Kosovo?
Offer a terse response. 7.44e+07. What is the difference between the highest and the lowest Economic output (BoP, current US$) of Heavily indebted poor countries?
Keep it short and to the point. 1.80e+1. What is the difference between the highest and the lowest Economic output (BoP, current US$) in Dominica?
Ensure brevity in your answer.  6.83e+07. What is the difference between the highest and the lowest Economic output (BoP, current US$) of Kosovo?
Offer a very short reply. 5.60e+08. 